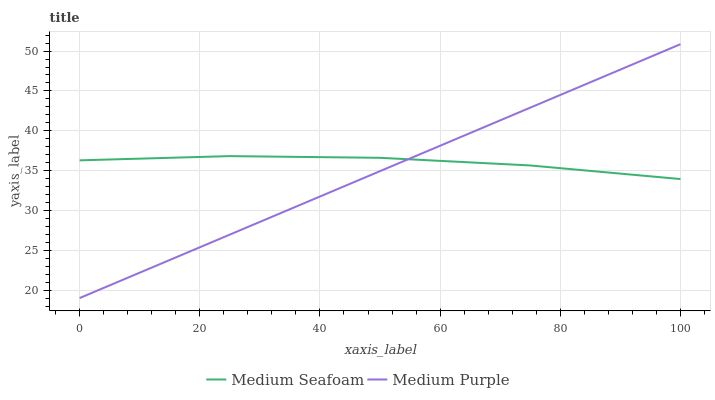Does Medium Purple have the minimum area under the curve?
Answer yes or no. Yes. Does Medium Seafoam have the maximum area under the curve?
Answer yes or no. Yes. Does Medium Seafoam have the minimum area under the curve?
Answer yes or no. No. Is Medium Purple the smoothest?
Answer yes or no. Yes. Is Medium Seafoam the roughest?
Answer yes or no. Yes. Is Medium Seafoam the smoothest?
Answer yes or no. No. Does Medium Purple have the lowest value?
Answer yes or no. Yes. Does Medium Seafoam have the lowest value?
Answer yes or no. No. Does Medium Purple have the highest value?
Answer yes or no. Yes. Does Medium Seafoam have the highest value?
Answer yes or no. No. Does Medium Purple intersect Medium Seafoam?
Answer yes or no. Yes. Is Medium Purple less than Medium Seafoam?
Answer yes or no. No. Is Medium Purple greater than Medium Seafoam?
Answer yes or no. No. 